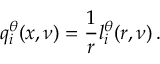Convert formula to latex. <formula><loc_0><loc_0><loc_500><loc_500>q _ { i } ^ { \theta } ( x , \nu ) = \frac { 1 } { r } l _ { i } ^ { \theta } ( r , \nu ) \, .</formula> 